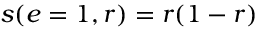Convert formula to latex. <formula><loc_0><loc_0><loc_500><loc_500>s ( e = 1 , r ) = r ( 1 - r )</formula> 